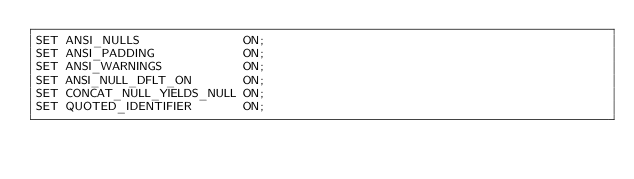Convert code to text. <code><loc_0><loc_0><loc_500><loc_500><_SQL_>SET ANSI_NULLS              ON;
SET ANSI_PADDING            ON;
SET ANSI_WARNINGS           ON;
SET ANSI_NULL_DFLT_ON       ON;
SET CONCAT_NULL_YIELDS_NULL ON;
SET QUOTED_IDENTIFIER       ON;</code> 